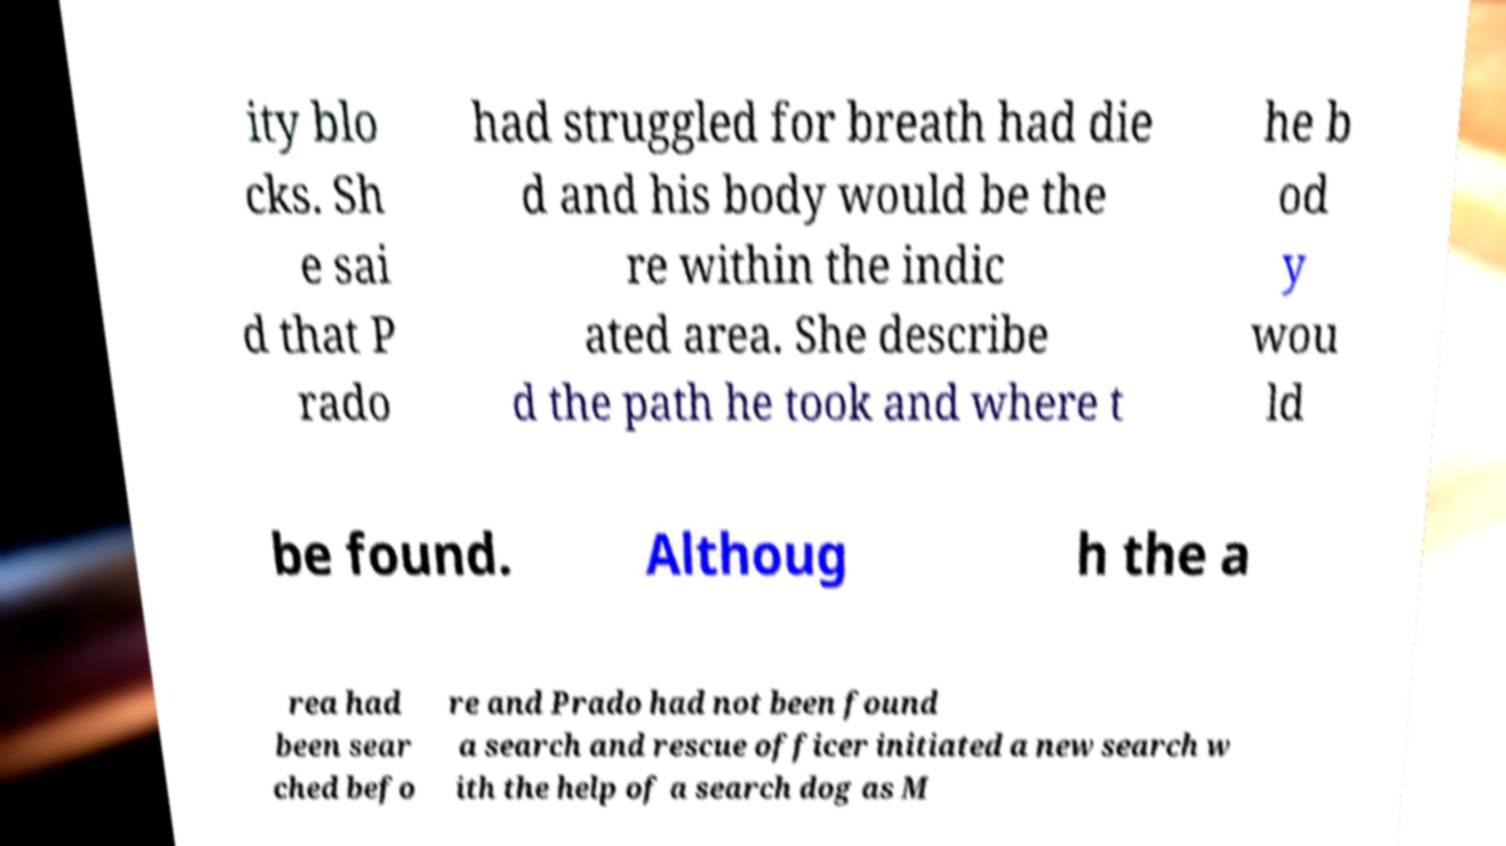For documentation purposes, I need the text within this image transcribed. Could you provide that? ity blo cks. Sh e sai d that P rado had struggled for breath had die d and his body would be the re within the indic ated area. She describe d the path he took and where t he b od y wou ld be found. Althoug h the a rea had been sear ched befo re and Prado had not been found a search and rescue officer initiated a new search w ith the help of a search dog as M 